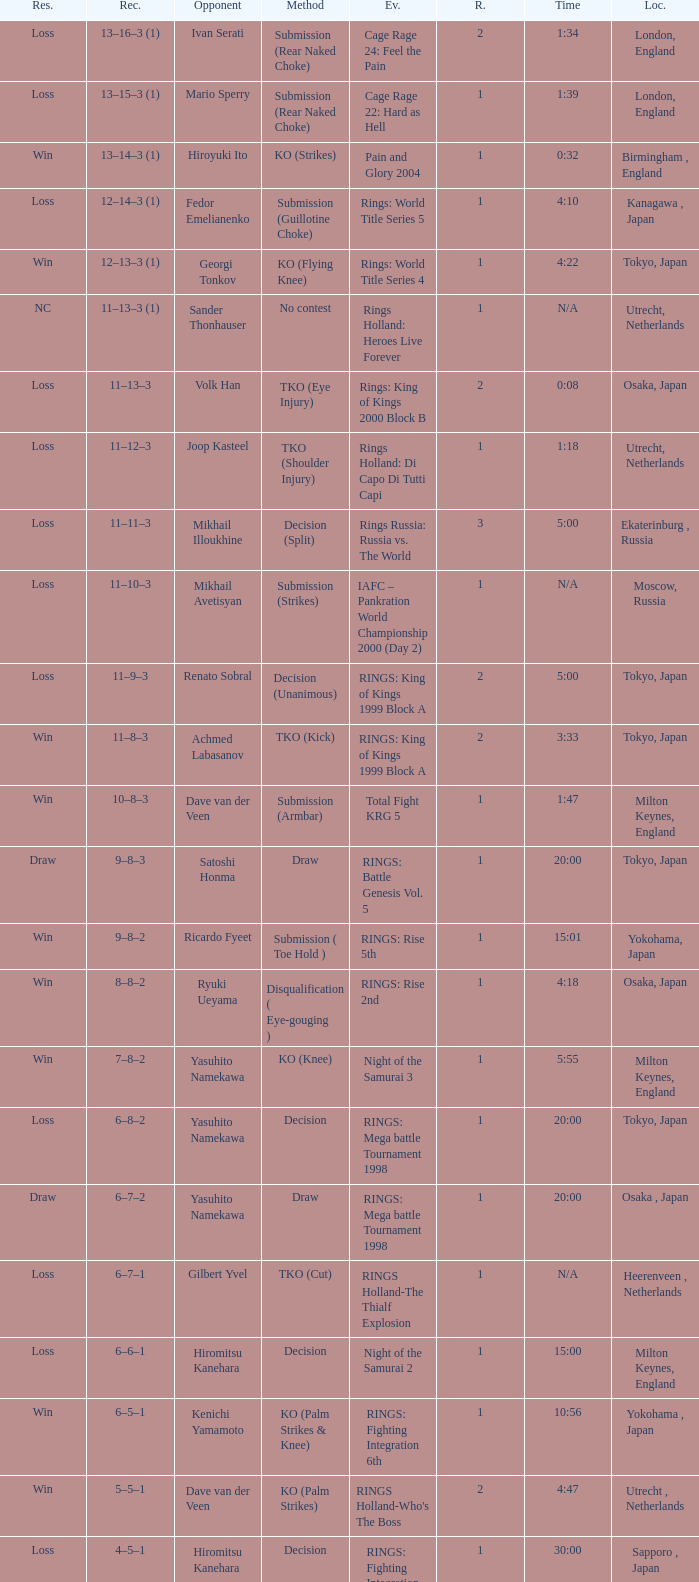At what time will an adversary of satoshi honma compete? 20:00. 